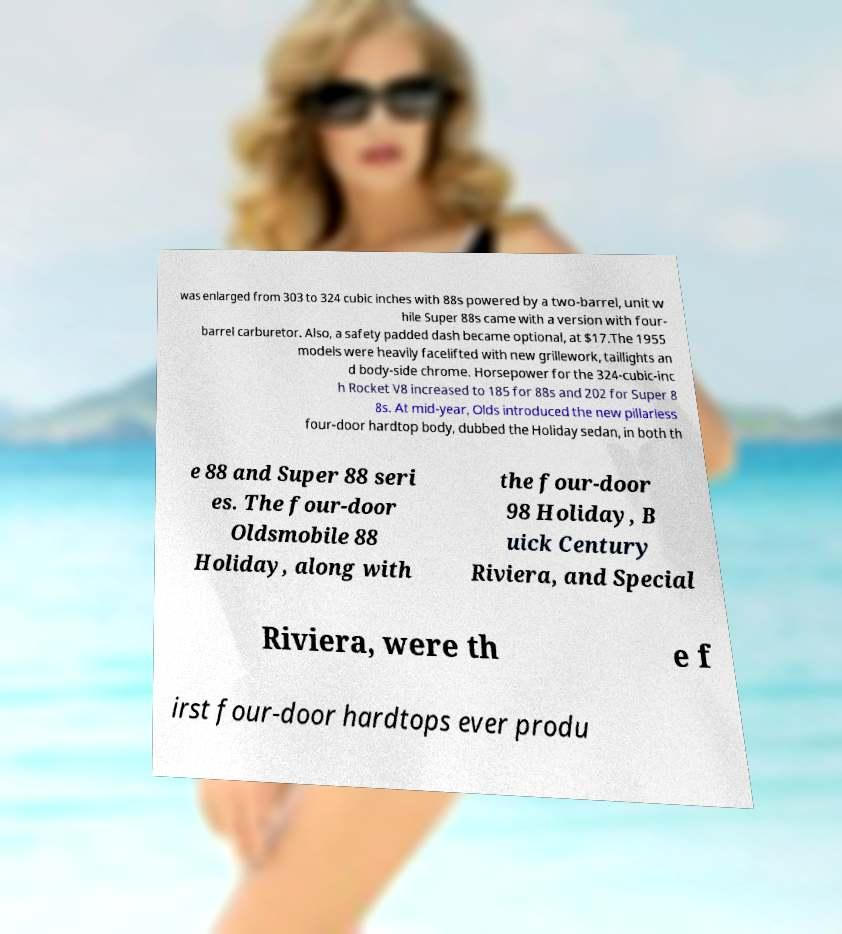Could you extract and type out the text from this image? was enlarged from 303 to 324 cubic inches with 88s powered by a two-barrel, unit w hile Super 88s came with a version with four- barrel carburetor. Also, a safety padded dash became optional, at $17.The 1955 models were heavily facelifted with new grillework, taillights an d body-side chrome. Horsepower for the 324-cubic-inc h Rocket V8 increased to 185 for 88s and 202 for Super 8 8s. At mid-year, Olds introduced the new pillarless four-door hardtop body, dubbed the Holiday sedan, in both th e 88 and Super 88 seri es. The four-door Oldsmobile 88 Holiday, along with the four-door 98 Holiday, B uick Century Riviera, and Special Riviera, were th e f irst four-door hardtops ever produ 